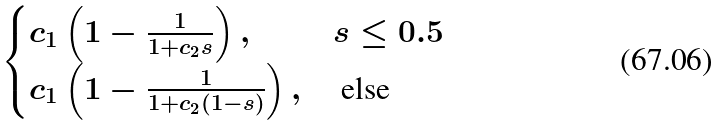Convert formula to latex. <formula><loc_0><loc_0><loc_500><loc_500>\begin{cases} c _ { 1 } \left ( 1 - \frac { 1 } { 1 + c _ { 2 } s } \right ) , & s \leq 0 . 5 \\ c _ { 1 } \left ( 1 - \frac { 1 } { 1 + c _ { 2 } ( 1 - s ) } \right ) , & \text { else} \end{cases}</formula> 